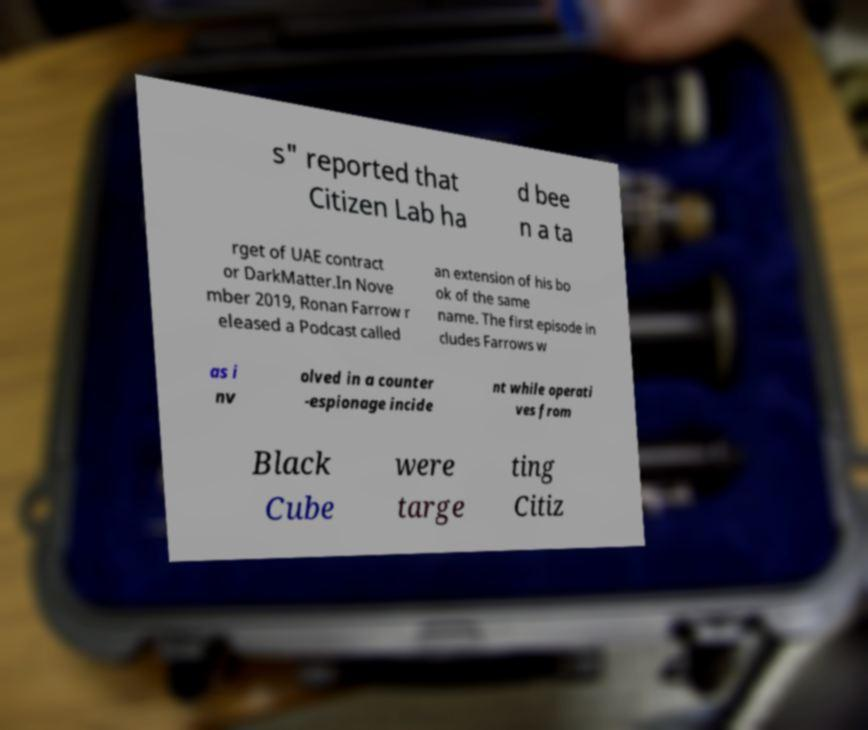What messages or text are displayed in this image? I need them in a readable, typed format. s" reported that Citizen Lab ha d bee n a ta rget of UAE contract or DarkMatter.In Nove mber 2019, Ronan Farrow r eleased a Podcast called an extension of his bo ok of the same name. The first episode in cludes Farrows w as i nv olved in a counter -espionage incide nt while operati ves from Black Cube were targe ting Citiz 